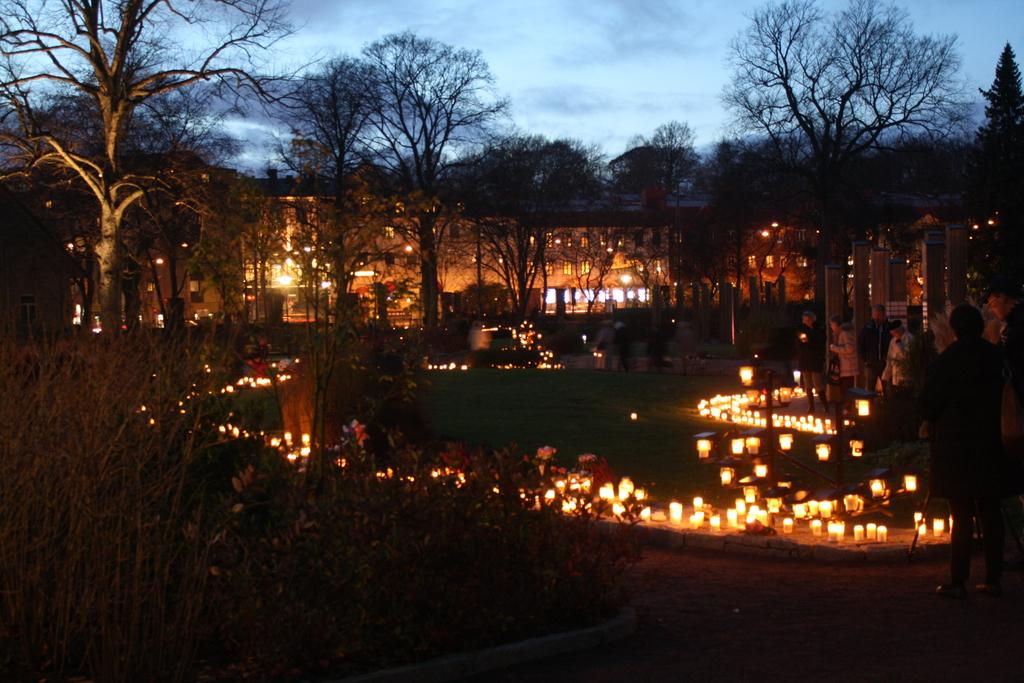What can be seen in the image that emit light? There are lights in the image that emit light. What type of structures are visible in the image? There are buildings in the image. What type of vegetation is present in the image? There are trees in the image. What part of the natural environment is visible in the image? The sky is visible in the image, and there are clouds present. How would you describe the overall lighting in the image? The image appears to be slightly dark. What type of grape is being eaten by your dad in the image? There is no dad or grape present in the image. What time of day is it in the image, based on the hour? The image does not provide information about the time of day or the hour. 